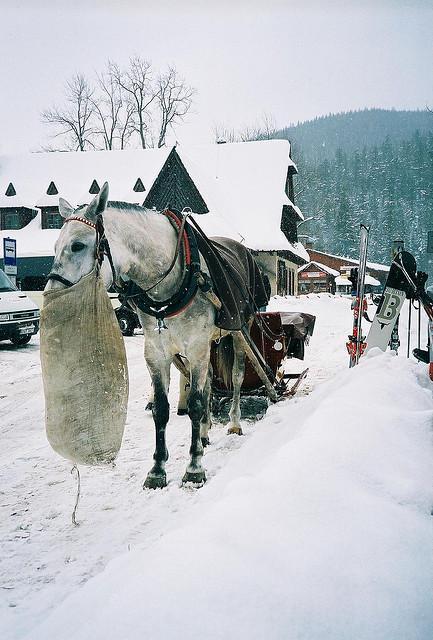The animal has how many legs?
Indicate the correct choice and explain in the format: 'Answer: answer
Rationale: rationale.'
Options: Four, eight, six, two. Answer: four.
Rationale: The horse is standing on four legs in the snow. 